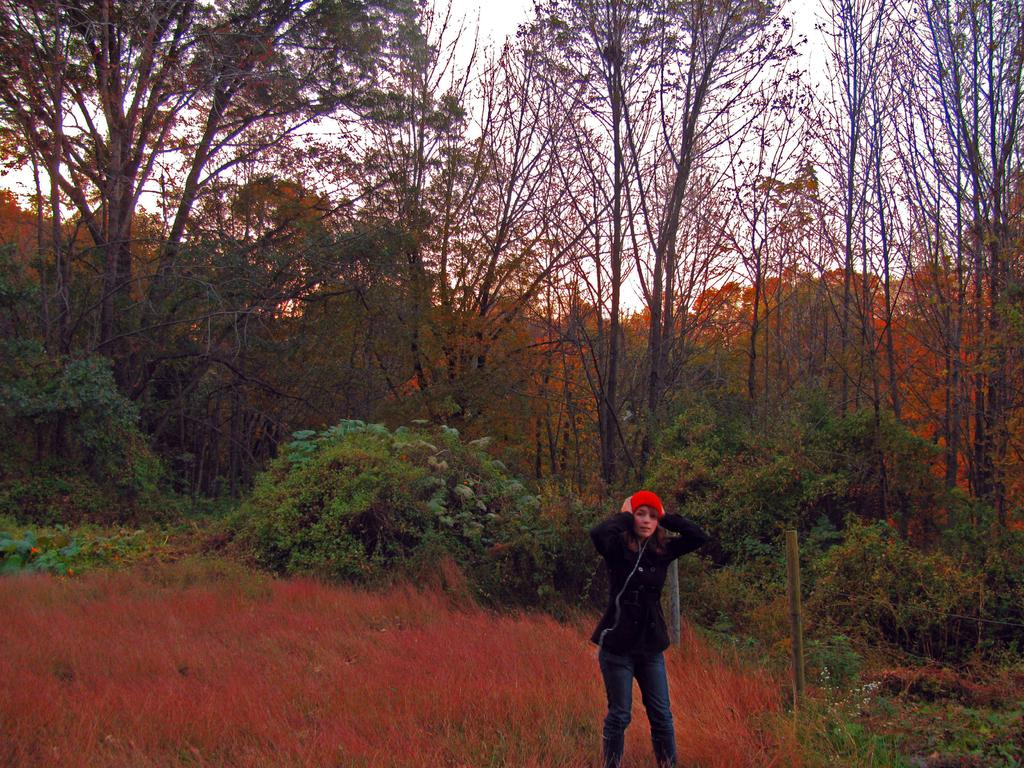Who is the main subject in the image? There is a woman standing in the center of the image. What can be seen in the background of the image? There are trees in the background of the image. What type of vegetation is present in the image? There are plants in the image. What is the ground covered with in the image? There is grass on the ground in the image. What type of dinner is being served in the image? There is no dinner present in the image; it features a woman standing in the center with trees, plants, and grass in the background. 